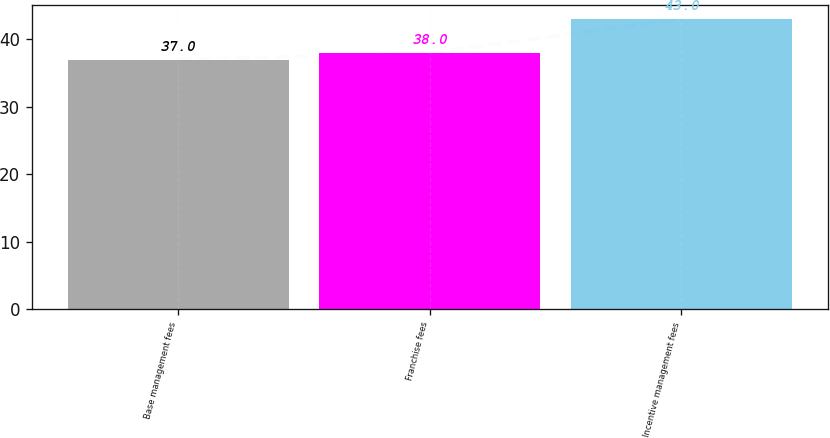<chart> <loc_0><loc_0><loc_500><loc_500><bar_chart><fcel>Base management fees<fcel>Franchise fees<fcel>Incentive management fees<nl><fcel>37<fcel>38<fcel>43<nl></chart> 